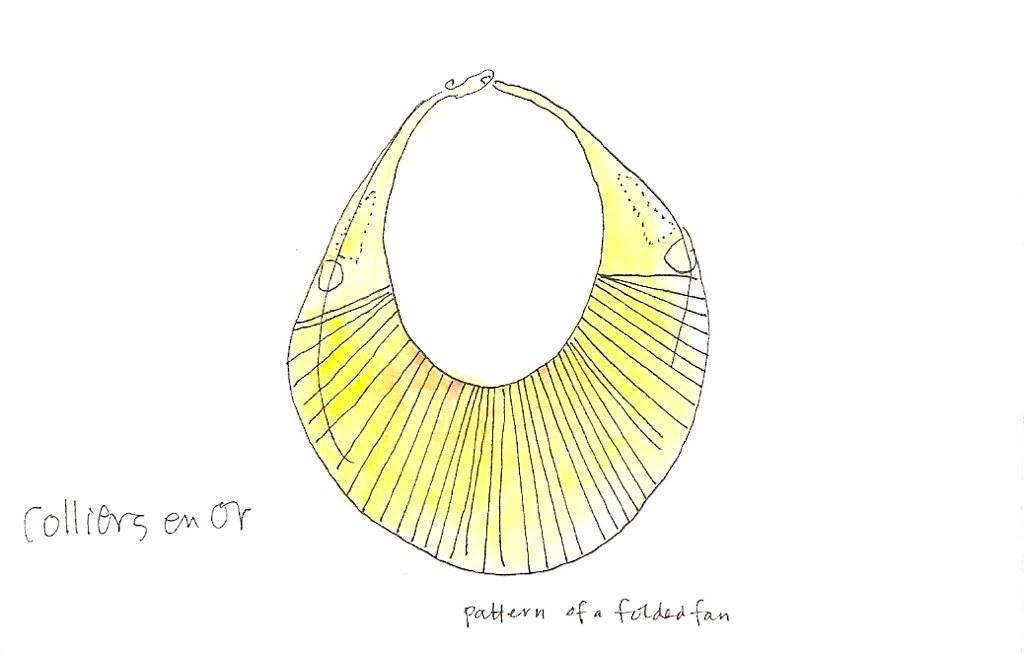What type of image is being described? The image is a drawing. How long is the snake in the drawing? There is no snake present in the drawing; it is a simple statement that the image is a drawing. 